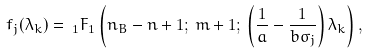Convert formula to latex. <formula><loc_0><loc_0><loc_500><loc_500>f _ { j } ( \lambda _ { k } ) = \, _ { 1 } F _ { 1 } \left ( n _ { B } - n + 1 ; \, m + 1 ; \, \left ( \frac { 1 } { a } - \frac { 1 } { b \sigma _ { j } } \right ) \lambda _ { k } \right ) ,</formula> 